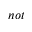<formula> <loc_0><loc_0><loc_500><loc_500>n o t</formula> 